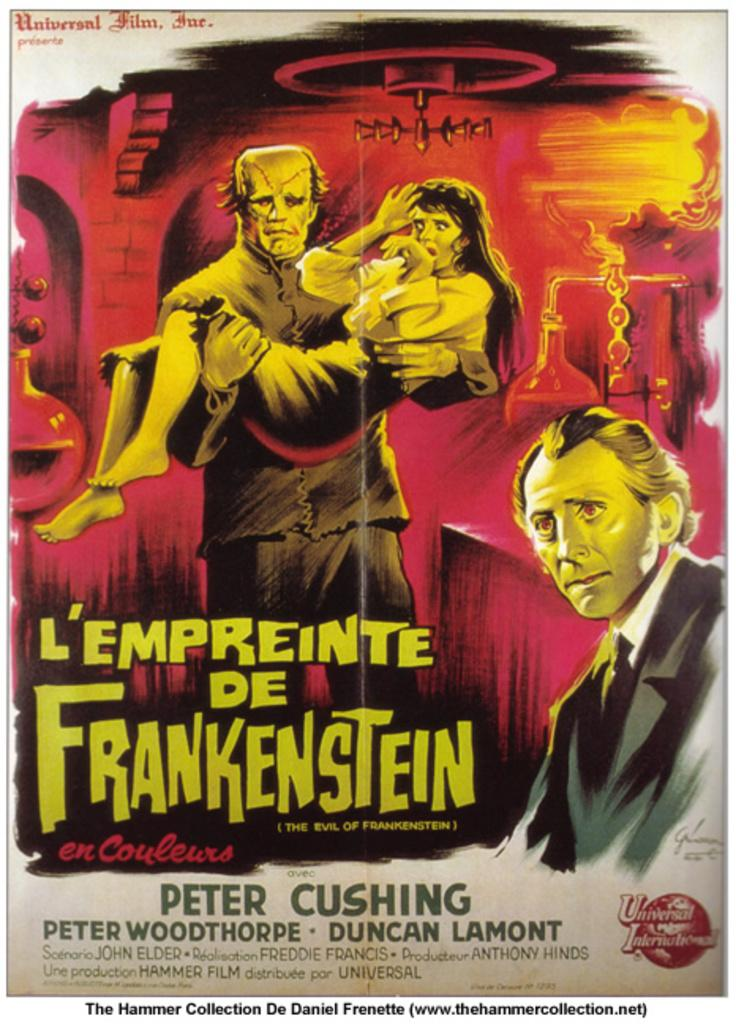Provide a one-sentence caption for the provided image. A poster for a movie that stars Peter Cushing. 